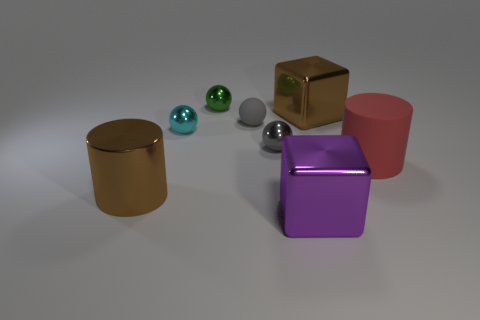What number of objects are either large brown metal things that are behind the red cylinder or brown shiny objects that are in front of the red cylinder?
Your response must be concise. 2. How many metal things are behind the brown metallic thing that is behind the large brown shiny cylinder?
Make the answer very short. 1. There is a cylinder that is made of the same material as the purple object; what color is it?
Provide a succinct answer. Brown. Is there a shiny object of the same size as the red matte cylinder?
Your answer should be compact. Yes. What shape is the rubber thing that is the same size as the purple metal cube?
Make the answer very short. Cylinder. Are there any large purple objects that have the same shape as the big red matte thing?
Your response must be concise. No. Are the big red object and the large brown object that is to the left of the big brown shiny block made of the same material?
Your answer should be compact. No. Are there any large shiny cylinders that have the same color as the large matte object?
Make the answer very short. No. How many other things are made of the same material as the green thing?
Your answer should be very brief. 5. There is a rubber cylinder; is it the same color as the big cylinder that is on the left side of the tiny gray shiny object?
Provide a succinct answer. No. 